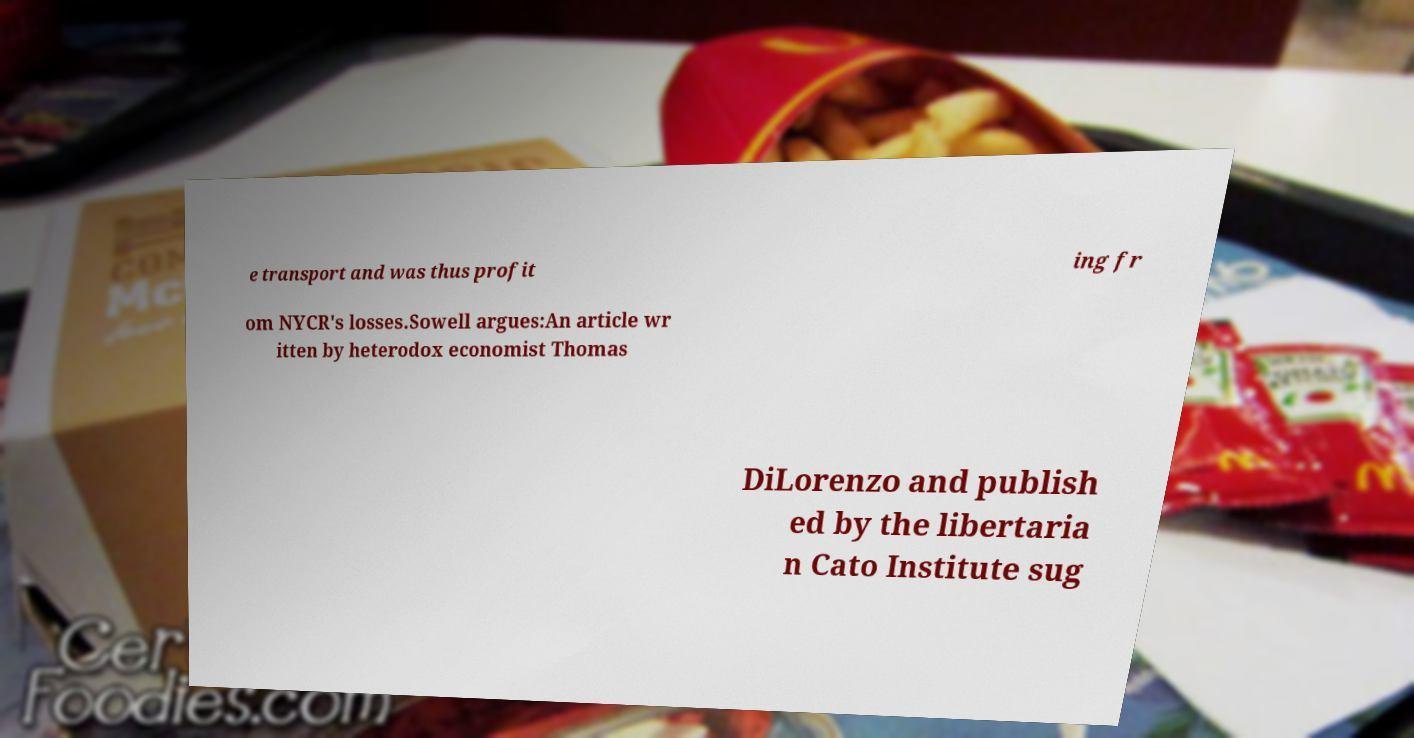Could you extract and type out the text from this image? e transport and was thus profit ing fr om NYCR's losses.Sowell argues:An article wr itten by heterodox economist Thomas DiLorenzo and publish ed by the libertaria n Cato Institute sug 